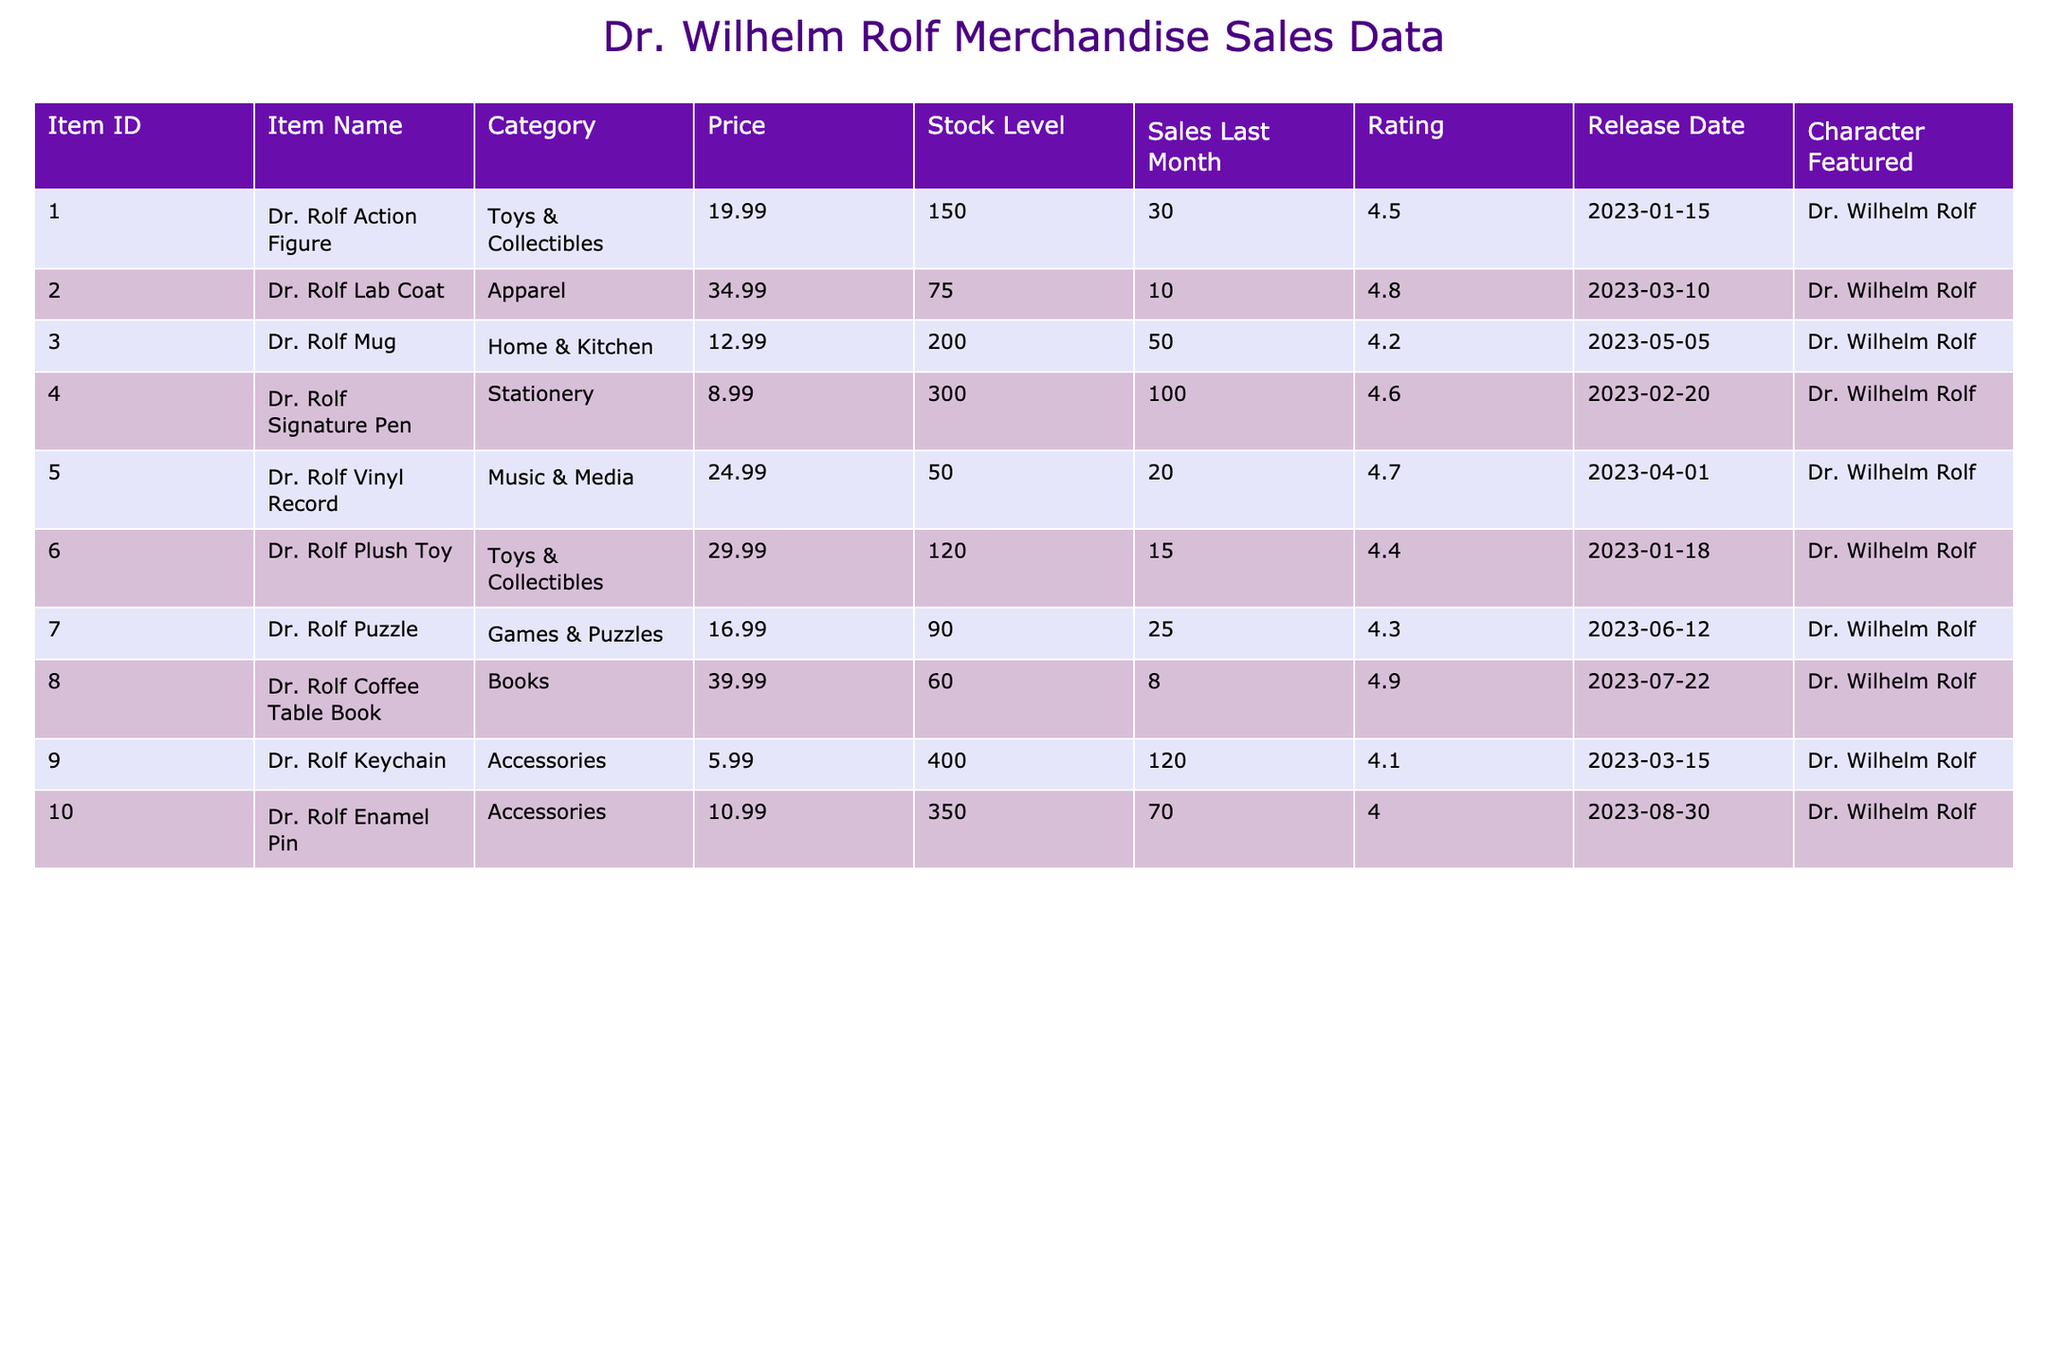What is the price of the Dr. Rolf Mug? The Dr. Rolf Mug's price is explicitly listed under the "Price" column in the table, which shows it to be 12.99.
Answer: 12.99 How many units of the Dr. Rolf Lab Coat are in stock? The "Stock Level" column shows that the Dr. Rolf Lab Coat has 75 units available.
Answer: 75 What is the average rating of all items featuring Dr. Wilhelm Rolf? To find the average rating, sum the ratings: (4.5 + 4.8 + 4.2 + 4.6 + 4.7 + 4.4 + 4.3 + 4.9 + 4.1 + 4.0) = 46.5. There are 10 items, so the average is 46.5 / 10 = 4.65.
Answer: 4.65 Which item has the highest stock level? By comparing the "Stock Level" values across all items, the Dr. Rolf Keychain has the highest stock level at 400.
Answer: Dr. Rolf Keychain How many sales did the Dr. Rolf Puzzle have last month? The "Sales Last Month" column indicates that there were 25 sales for the Dr. Rolf Puzzle last month.
Answer: 25 What is the total revenue generated from the Dr. Rolf Action Figure last month? The total revenue can be calculated by multiplying the number of sales (30) by the price (19.99): 30 * 19.99 = 599.70.
Answer: 599.70 Is the Dr. Rolf Vinyl Record priced higher than the Dr. Rolf Plush Toy? The Dr. Rolf Vinyl Record is priced at 24.99, while the Dr. Rolf Plush Toy is priced at 29.99. Since 24.99 is less than 29.99, the statement is false.
Answer: No Which item had the lowest sales last month? By reviewing the "Sales Last Month" column, the Dr. Rolf Coffee Table Book had the lowest sales at 8 units.
Answer: Dr. Rolf Coffee Table Book What is the stock level of items categorized under "Toys & Collectibles"? The stock levels for items in this category are: Dr. Rolf Action Figure (150) and Dr. Rolf Plush Toy (120), summing them gives a total stock level of 270.
Answer: 270 How many items have a rating of 4.5 or higher? Analyzing the "Rating" column, the items with ratings of 4.5 or higher are: Dr. Rolf Action Figure, Dr. Rolf Lab Coat, Dr. Rolf Vinyl Record, Dr. Rolf Sign Pen, Dr. Rolf Coffee Table Book which makes a total of 6 items.
Answer: 6 